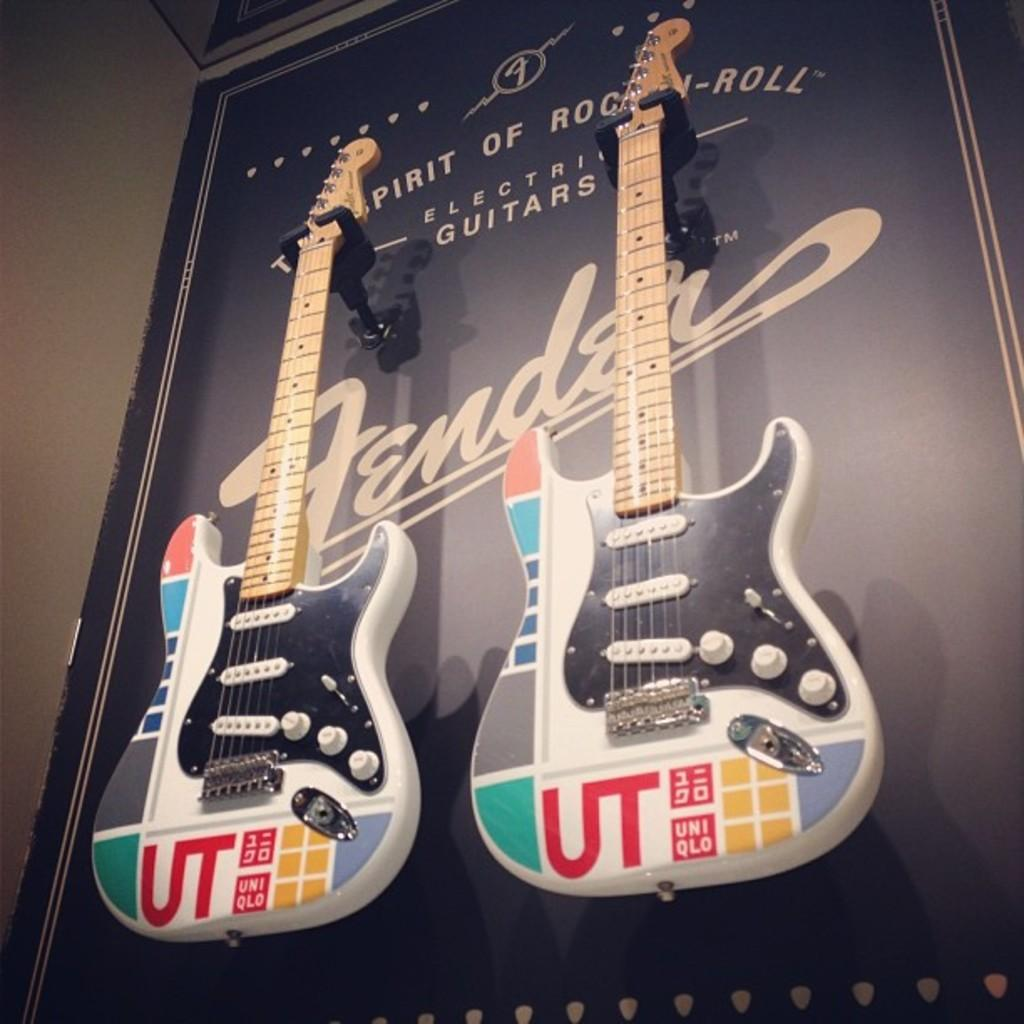What musical instruments are present in the image? There are two guitars in the image. How are the guitars positioned in the image? The guitars are placed on stands. Where are the stands located in the image? The stands are on the wall. What type of paste is being used to create a circle on the wall in the image? There is no paste or circle present in the image; it only features two guitars on stands on the wall. 